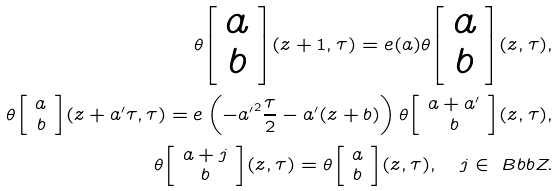Convert formula to latex. <formula><loc_0><loc_0><loc_500><loc_500>\theta { \left [ \begin{array} { c } a \\ b \end{array} \right ] } ( z + 1 , \tau ) = { e } ( a ) \theta { \left [ \begin{array} { c } a \\ b \end{array} \right ] } ( z , \tau ) , \\ \theta { \left [ \begin{array} { c } a \\ b \end{array} \right ] } ( z + a ^ { \prime } \tau , \tau ) = { e } \left ( - { a ^ { \prime } } ^ { 2 } \frac { \tau } { 2 } - a ^ { \prime } ( z + b ) \right ) \theta { \left [ \begin{array} { c } a + a ^ { \prime } \\ b \end{array} \right ] } ( z , \tau ) , \\ \theta { \left [ \begin{array} { c } a + j \\ b \end{array} \right ] } ( z , \tau ) = \theta { \left [ \begin{array} { c } a \\ b \end{array} \right ] } ( z , \tau ) , \quad j \in \ B b b Z .</formula> 